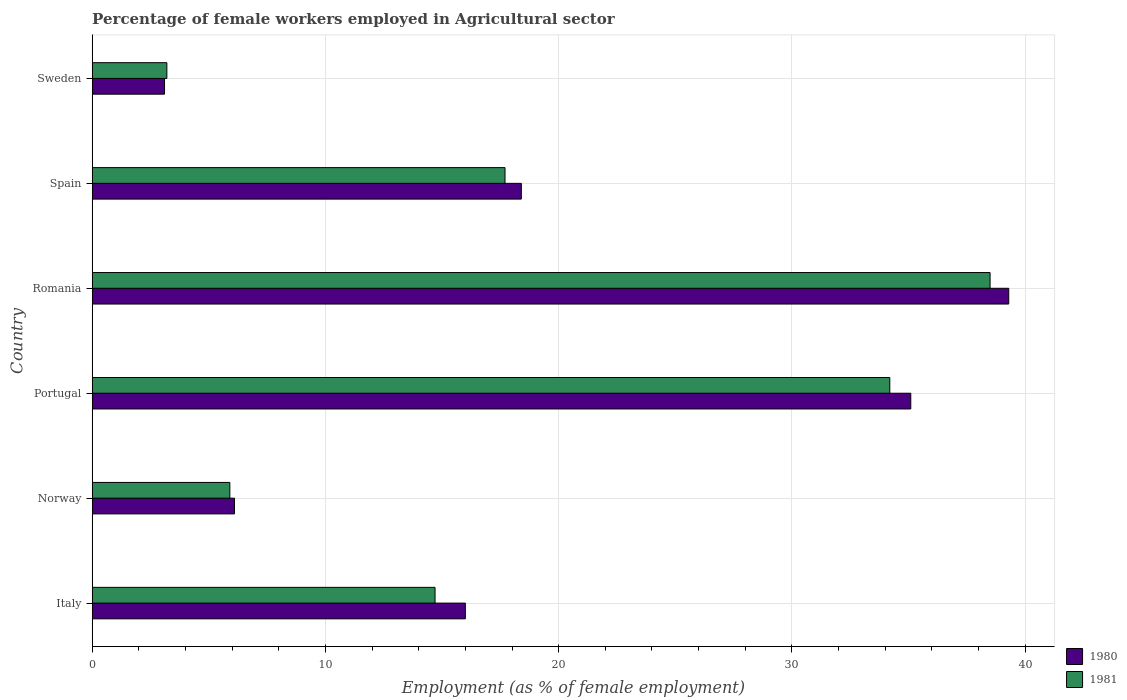How many groups of bars are there?
Make the answer very short. 6. How many bars are there on the 4th tick from the top?
Your response must be concise. 2. How many bars are there on the 3rd tick from the bottom?
Give a very brief answer. 2. What is the label of the 4th group of bars from the top?
Keep it short and to the point. Portugal. In how many cases, is the number of bars for a given country not equal to the number of legend labels?
Your answer should be very brief. 0. What is the percentage of females employed in Agricultural sector in 1980 in Portugal?
Make the answer very short. 35.1. Across all countries, what is the maximum percentage of females employed in Agricultural sector in 1981?
Your answer should be compact. 38.5. Across all countries, what is the minimum percentage of females employed in Agricultural sector in 1981?
Your response must be concise. 3.2. In which country was the percentage of females employed in Agricultural sector in 1981 maximum?
Make the answer very short. Romania. What is the total percentage of females employed in Agricultural sector in 1981 in the graph?
Your answer should be compact. 114.2. What is the difference between the percentage of females employed in Agricultural sector in 1980 in Italy and that in Norway?
Give a very brief answer. 9.9. What is the difference between the percentage of females employed in Agricultural sector in 1981 in Spain and the percentage of females employed in Agricultural sector in 1980 in Sweden?
Make the answer very short. 14.6. What is the average percentage of females employed in Agricultural sector in 1980 per country?
Give a very brief answer. 19.67. What is the difference between the percentage of females employed in Agricultural sector in 1981 and percentage of females employed in Agricultural sector in 1980 in Norway?
Give a very brief answer. -0.2. In how many countries, is the percentage of females employed in Agricultural sector in 1981 greater than 28 %?
Make the answer very short. 2. What is the ratio of the percentage of females employed in Agricultural sector in 1980 in Romania to that in Spain?
Offer a terse response. 2.14. Is the difference between the percentage of females employed in Agricultural sector in 1981 in Norway and Portugal greater than the difference between the percentage of females employed in Agricultural sector in 1980 in Norway and Portugal?
Your answer should be compact. Yes. What is the difference between the highest and the second highest percentage of females employed in Agricultural sector in 1980?
Your answer should be very brief. 4.2. What is the difference between the highest and the lowest percentage of females employed in Agricultural sector in 1981?
Ensure brevity in your answer.  35.3. Is the sum of the percentage of females employed in Agricultural sector in 1981 in Romania and Sweden greater than the maximum percentage of females employed in Agricultural sector in 1980 across all countries?
Your answer should be compact. Yes. What does the 2nd bar from the top in Italy represents?
Ensure brevity in your answer.  1980. How many bars are there?
Give a very brief answer. 12. Are all the bars in the graph horizontal?
Provide a succinct answer. Yes. What is the difference between two consecutive major ticks on the X-axis?
Give a very brief answer. 10. Does the graph contain any zero values?
Your answer should be very brief. No. Where does the legend appear in the graph?
Ensure brevity in your answer.  Bottom right. How are the legend labels stacked?
Your response must be concise. Vertical. What is the title of the graph?
Provide a short and direct response. Percentage of female workers employed in Agricultural sector. Does "2010" appear as one of the legend labels in the graph?
Make the answer very short. No. What is the label or title of the X-axis?
Your answer should be compact. Employment (as % of female employment). What is the label or title of the Y-axis?
Offer a terse response. Country. What is the Employment (as % of female employment) in 1980 in Italy?
Ensure brevity in your answer.  16. What is the Employment (as % of female employment) of 1981 in Italy?
Offer a very short reply. 14.7. What is the Employment (as % of female employment) in 1980 in Norway?
Make the answer very short. 6.1. What is the Employment (as % of female employment) of 1981 in Norway?
Provide a short and direct response. 5.9. What is the Employment (as % of female employment) in 1980 in Portugal?
Give a very brief answer. 35.1. What is the Employment (as % of female employment) in 1981 in Portugal?
Give a very brief answer. 34.2. What is the Employment (as % of female employment) of 1980 in Romania?
Make the answer very short. 39.3. What is the Employment (as % of female employment) of 1981 in Romania?
Keep it short and to the point. 38.5. What is the Employment (as % of female employment) of 1980 in Spain?
Ensure brevity in your answer.  18.4. What is the Employment (as % of female employment) in 1981 in Spain?
Provide a short and direct response. 17.7. What is the Employment (as % of female employment) in 1980 in Sweden?
Make the answer very short. 3.1. What is the Employment (as % of female employment) in 1981 in Sweden?
Provide a short and direct response. 3.2. Across all countries, what is the maximum Employment (as % of female employment) in 1980?
Offer a very short reply. 39.3. Across all countries, what is the maximum Employment (as % of female employment) of 1981?
Provide a short and direct response. 38.5. Across all countries, what is the minimum Employment (as % of female employment) in 1980?
Make the answer very short. 3.1. Across all countries, what is the minimum Employment (as % of female employment) of 1981?
Ensure brevity in your answer.  3.2. What is the total Employment (as % of female employment) of 1980 in the graph?
Give a very brief answer. 118. What is the total Employment (as % of female employment) of 1981 in the graph?
Your response must be concise. 114.2. What is the difference between the Employment (as % of female employment) in 1981 in Italy and that in Norway?
Provide a short and direct response. 8.8. What is the difference between the Employment (as % of female employment) in 1980 in Italy and that in Portugal?
Ensure brevity in your answer.  -19.1. What is the difference between the Employment (as % of female employment) of 1981 in Italy and that in Portugal?
Your answer should be very brief. -19.5. What is the difference between the Employment (as % of female employment) in 1980 in Italy and that in Romania?
Provide a succinct answer. -23.3. What is the difference between the Employment (as % of female employment) of 1981 in Italy and that in Romania?
Make the answer very short. -23.8. What is the difference between the Employment (as % of female employment) in 1981 in Italy and that in Spain?
Make the answer very short. -3. What is the difference between the Employment (as % of female employment) in 1981 in Norway and that in Portugal?
Offer a very short reply. -28.3. What is the difference between the Employment (as % of female employment) in 1980 in Norway and that in Romania?
Offer a very short reply. -33.2. What is the difference between the Employment (as % of female employment) in 1981 in Norway and that in Romania?
Your answer should be compact. -32.6. What is the difference between the Employment (as % of female employment) of 1981 in Norway and that in Sweden?
Your response must be concise. 2.7. What is the difference between the Employment (as % of female employment) of 1980 in Portugal and that in Romania?
Offer a very short reply. -4.2. What is the difference between the Employment (as % of female employment) in 1980 in Portugal and that in Spain?
Provide a short and direct response. 16.7. What is the difference between the Employment (as % of female employment) of 1981 in Portugal and that in Spain?
Offer a terse response. 16.5. What is the difference between the Employment (as % of female employment) of 1980 in Romania and that in Spain?
Make the answer very short. 20.9. What is the difference between the Employment (as % of female employment) of 1981 in Romania and that in Spain?
Offer a very short reply. 20.8. What is the difference between the Employment (as % of female employment) in 1980 in Romania and that in Sweden?
Keep it short and to the point. 36.2. What is the difference between the Employment (as % of female employment) in 1981 in Romania and that in Sweden?
Provide a succinct answer. 35.3. What is the difference between the Employment (as % of female employment) in 1981 in Spain and that in Sweden?
Provide a short and direct response. 14.5. What is the difference between the Employment (as % of female employment) in 1980 in Italy and the Employment (as % of female employment) in 1981 in Norway?
Your answer should be compact. 10.1. What is the difference between the Employment (as % of female employment) in 1980 in Italy and the Employment (as % of female employment) in 1981 in Portugal?
Keep it short and to the point. -18.2. What is the difference between the Employment (as % of female employment) in 1980 in Italy and the Employment (as % of female employment) in 1981 in Romania?
Your response must be concise. -22.5. What is the difference between the Employment (as % of female employment) of 1980 in Italy and the Employment (as % of female employment) of 1981 in Sweden?
Your response must be concise. 12.8. What is the difference between the Employment (as % of female employment) of 1980 in Norway and the Employment (as % of female employment) of 1981 in Portugal?
Give a very brief answer. -28.1. What is the difference between the Employment (as % of female employment) in 1980 in Norway and the Employment (as % of female employment) in 1981 in Romania?
Provide a short and direct response. -32.4. What is the difference between the Employment (as % of female employment) of 1980 in Norway and the Employment (as % of female employment) of 1981 in Spain?
Make the answer very short. -11.6. What is the difference between the Employment (as % of female employment) of 1980 in Norway and the Employment (as % of female employment) of 1981 in Sweden?
Offer a very short reply. 2.9. What is the difference between the Employment (as % of female employment) in 1980 in Portugal and the Employment (as % of female employment) in 1981 in Spain?
Ensure brevity in your answer.  17.4. What is the difference between the Employment (as % of female employment) of 1980 in Portugal and the Employment (as % of female employment) of 1981 in Sweden?
Provide a succinct answer. 31.9. What is the difference between the Employment (as % of female employment) in 1980 in Romania and the Employment (as % of female employment) in 1981 in Spain?
Offer a terse response. 21.6. What is the difference between the Employment (as % of female employment) of 1980 in Romania and the Employment (as % of female employment) of 1981 in Sweden?
Make the answer very short. 36.1. What is the difference between the Employment (as % of female employment) of 1980 in Spain and the Employment (as % of female employment) of 1981 in Sweden?
Keep it short and to the point. 15.2. What is the average Employment (as % of female employment) in 1980 per country?
Ensure brevity in your answer.  19.67. What is the average Employment (as % of female employment) in 1981 per country?
Offer a terse response. 19.03. What is the difference between the Employment (as % of female employment) of 1980 and Employment (as % of female employment) of 1981 in Romania?
Give a very brief answer. 0.8. What is the difference between the Employment (as % of female employment) of 1980 and Employment (as % of female employment) of 1981 in Sweden?
Offer a terse response. -0.1. What is the ratio of the Employment (as % of female employment) in 1980 in Italy to that in Norway?
Provide a short and direct response. 2.62. What is the ratio of the Employment (as % of female employment) of 1981 in Italy to that in Norway?
Provide a short and direct response. 2.49. What is the ratio of the Employment (as % of female employment) in 1980 in Italy to that in Portugal?
Ensure brevity in your answer.  0.46. What is the ratio of the Employment (as % of female employment) in 1981 in Italy to that in Portugal?
Provide a succinct answer. 0.43. What is the ratio of the Employment (as % of female employment) in 1980 in Italy to that in Romania?
Your answer should be compact. 0.41. What is the ratio of the Employment (as % of female employment) of 1981 in Italy to that in Romania?
Keep it short and to the point. 0.38. What is the ratio of the Employment (as % of female employment) of 1980 in Italy to that in Spain?
Your response must be concise. 0.87. What is the ratio of the Employment (as % of female employment) of 1981 in Italy to that in Spain?
Your answer should be very brief. 0.83. What is the ratio of the Employment (as % of female employment) of 1980 in Italy to that in Sweden?
Provide a succinct answer. 5.16. What is the ratio of the Employment (as % of female employment) of 1981 in Italy to that in Sweden?
Your response must be concise. 4.59. What is the ratio of the Employment (as % of female employment) in 1980 in Norway to that in Portugal?
Offer a very short reply. 0.17. What is the ratio of the Employment (as % of female employment) in 1981 in Norway to that in Portugal?
Make the answer very short. 0.17. What is the ratio of the Employment (as % of female employment) of 1980 in Norway to that in Romania?
Keep it short and to the point. 0.16. What is the ratio of the Employment (as % of female employment) of 1981 in Norway to that in Romania?
Provide a succinct answer. 0.15. What is the ratio of the Employment (as % of female employment) in 1980 in Norway to that in Spain?
Offer a terse response. 0.33. What is the ratio of the Employment (as % of female employment) of 1980 in Norway to that in Sweden?
Provide a succinct answer. 1.97. What is the ratio of the Employment (as % of female employment) of 1981 in Norway to that in Sweden?
Give a very brief answer. 1.84. What is the ratio of the Employment (as % of female employment) of 1980 in Portugal to that in Romania?
Ensure brevity in your answer.  0.89. What is the ratio of the Employment (as % of female employment) in 1981 in Portugal to that in Romania?
Keep it short and to the point. 0.89. What is the ratio of the Employment (as % of female employment) of 1980 in Portugal to that in Spain?
Give a very brief answer. 1.91. What is the ratio of the Employment (as % of female employment) in 1981 in Portugal to that in Spain?
Keep it short and to the point. 1.93. What is the ratio of the Employment (as % of female employment) in 1980 in Portugal to that in Sweden?
Make the answer very short. 11.32. What is the ratio of the Employment (as % of female employment) in 1981 in Portugal to that in Sweden?
Make the answer very short. 10.69. What is the ratio of the Employment (as % of female employment) in 1980 in Romania to that in Spain?
Offer a very short reply. 2.14. What is the ratio of the Employment (as % of female employment) in 1981 in Romania to that in Spain?
Keep it short and to the point. 2.18. What is the ratio of the Employment (as % of female employment) of 1980 in Romania to that in Sweden?
Your answer should be very brief. 12.68. What is the ratio of the Employment (as % of female employment) in 1981 in Romania to that in Sweden?
Ensure brevity in your answer.  12.03. What is the ratio of the Employment (as % of female employment) in 1980 in Spain to that in Sweden?
Give a very brief answer. 5.94. What is the ratio of the Employment (as % of female employment) in 1981 in Spain to that in Sweden?
Provide a short and direct response. 5.53. What is the difference between the highest and the second highest Employment (as % of female employment) of 1980?
Your answer should be very brief. 4.2. What is the difference between the highest and the lowest Employment (as % of female employment) of 1980?
Your answer should be very brief. 36.2. What is the difference between the highest and the lowest Employment (as % of female employment) of 1981?
Make the answer very short. 35.3. 